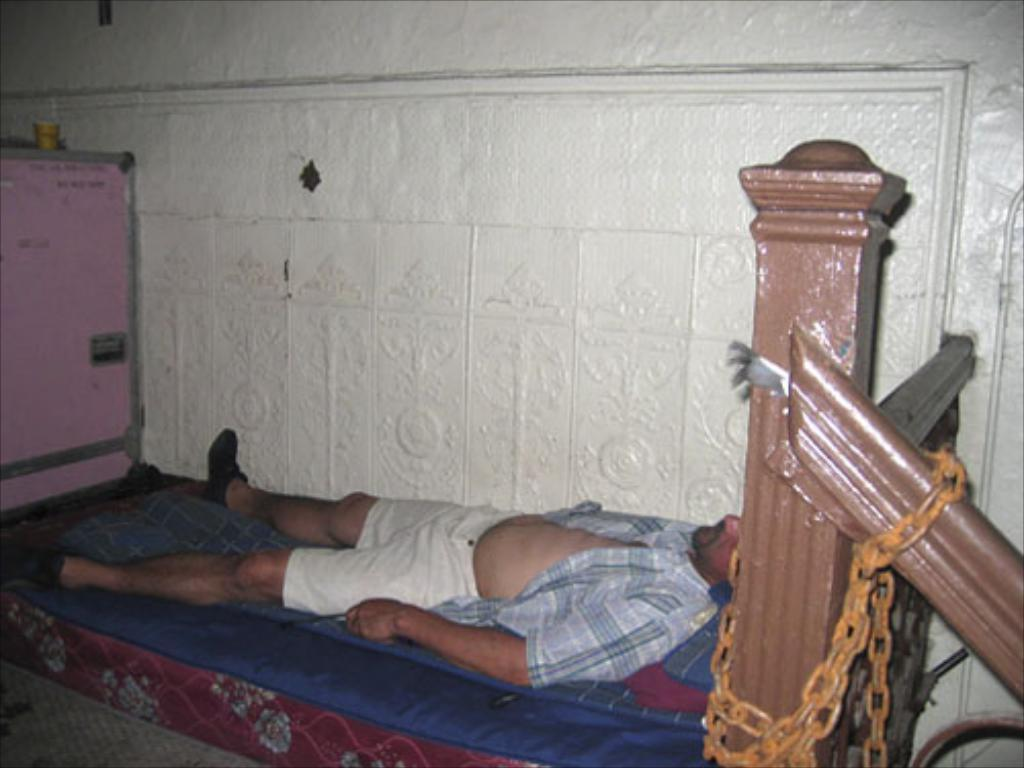Who is present in the image? There is a man in the image. What is the man doing in the image? The man is sleeping on a bed. Where is the bed located in the image? The bed is on the floor. What can be seen beside the man in the image? There is a wall beside the man. What is the wooden railing with a chain attached to it used for in the image? The purpose of the wooden railing with a chain attached to it is not explicitly stated in the facts, but it could potentially be used for security or to prevent the man from rolling off the bed. What color are the man's eyes in the image? The facts provided do not mention the color of the man's eyes, so it cannot be determined from the image. Is there a banana being offered to the man in the image? There is no banana or any indication of an offer in the image. 